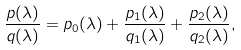<formula> <loc_0><loc_0><loc_500><loc_500>\frac { p ( \lambda ) } { q ( \lambda ) } = p _ { 0 } ( \lambda ) + \frac { p _ { 1 } ( \lambda ) } { q _ { 1 } ( \lambda ) } + \frac { p _ { 2 } ( \lambda ) } { q _ { 2 } ( \lambda ) } ,</formula> 